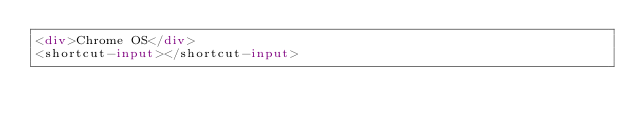Convert code to text. <code><loc_0><loc_0><loc_500><loc_500><_HTML_><div>Chrome OS</div>
<shortcut-input></shortcut-input></code> 